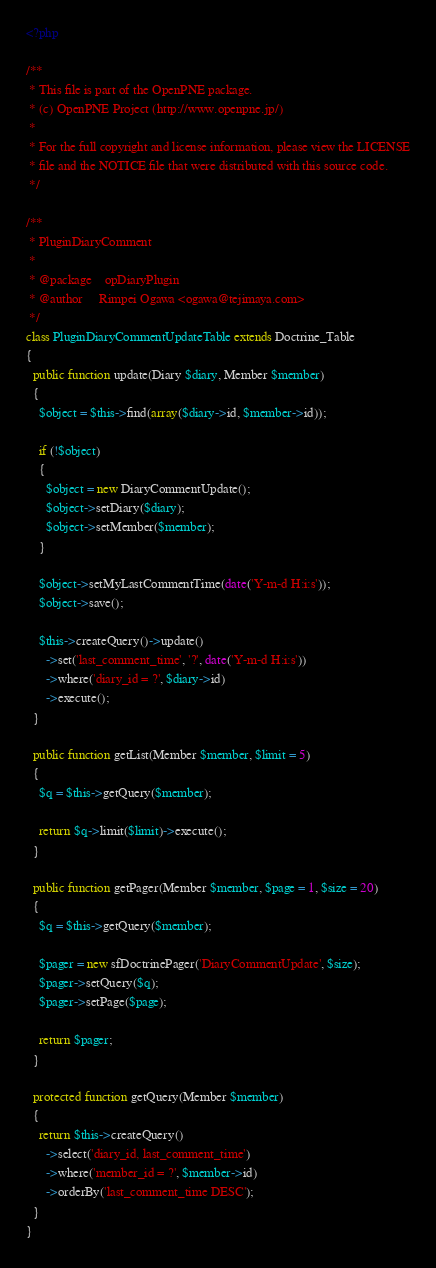Convert code to text. <code><loc_0><loc_0><loc_500><loc_500><_PHP_><?php

/**
 * This file is part of the OpenPNE package.
 * (c) OpenPNE Project (http://www.openpne.jp/)
 *
 * For the full copyright and license information, please view the LICENSE
 * file and the NOTICE file that were distributed with this source code.
 */

/**
 * PluginDiaryComment
 *
 * @package    opDiaryPlugin
 * @author     Rimpei Ogawa <ogawa@tejimaya.com>
 */
class PluginDiaryCommentUpdateTable extends Doctrine_Table
{
  public function update(Diary $diary, Member $member)
  {
    $object = $this->find(array($diary->id, $member->id));

    if (!$object)
    {
      $object = new DiaryCommentUpdate();
      $object->setDiary($diary);
      $object->setMember($member);
    }

    $object->setMyLastCommentTime(date('Y-m-d H:i:s'));
    $object->save();

    $this->createQuery()->update()
      ->set('last_comment_time', '?', date('Y-m-d H:i:s'))
      ->where('diary_id = ?', $diary->id)
      ->execute();
  }

  public function getList(Member $member, $limit = 5)
  {
    $q = $this->getQuery($member);

    return $q->limit($limit)->execute();
  }

  public function getPager(Member $member, $page = 1, $size = 20)
  {
    $q = $this->getQuery($member);

    $pager = new sfDoctrinePager('DiaryCommentUpdate', $size);
    $pager->setQuery($q);
    $pager->setPage($page);

    return $pager;
  }

  protected function getQuery(Member $member)
  {
    return $this->createQuery()
      ->select('diary_id, last_comment_time')
      ->where('member_id = ?', $member->id)
      ->orderBy('last_comment_time DESC');
  }
}
</code> 